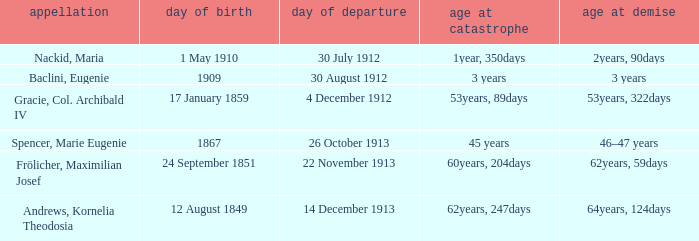What is the name of the person born in 1909? Baclini, Eugenie. 